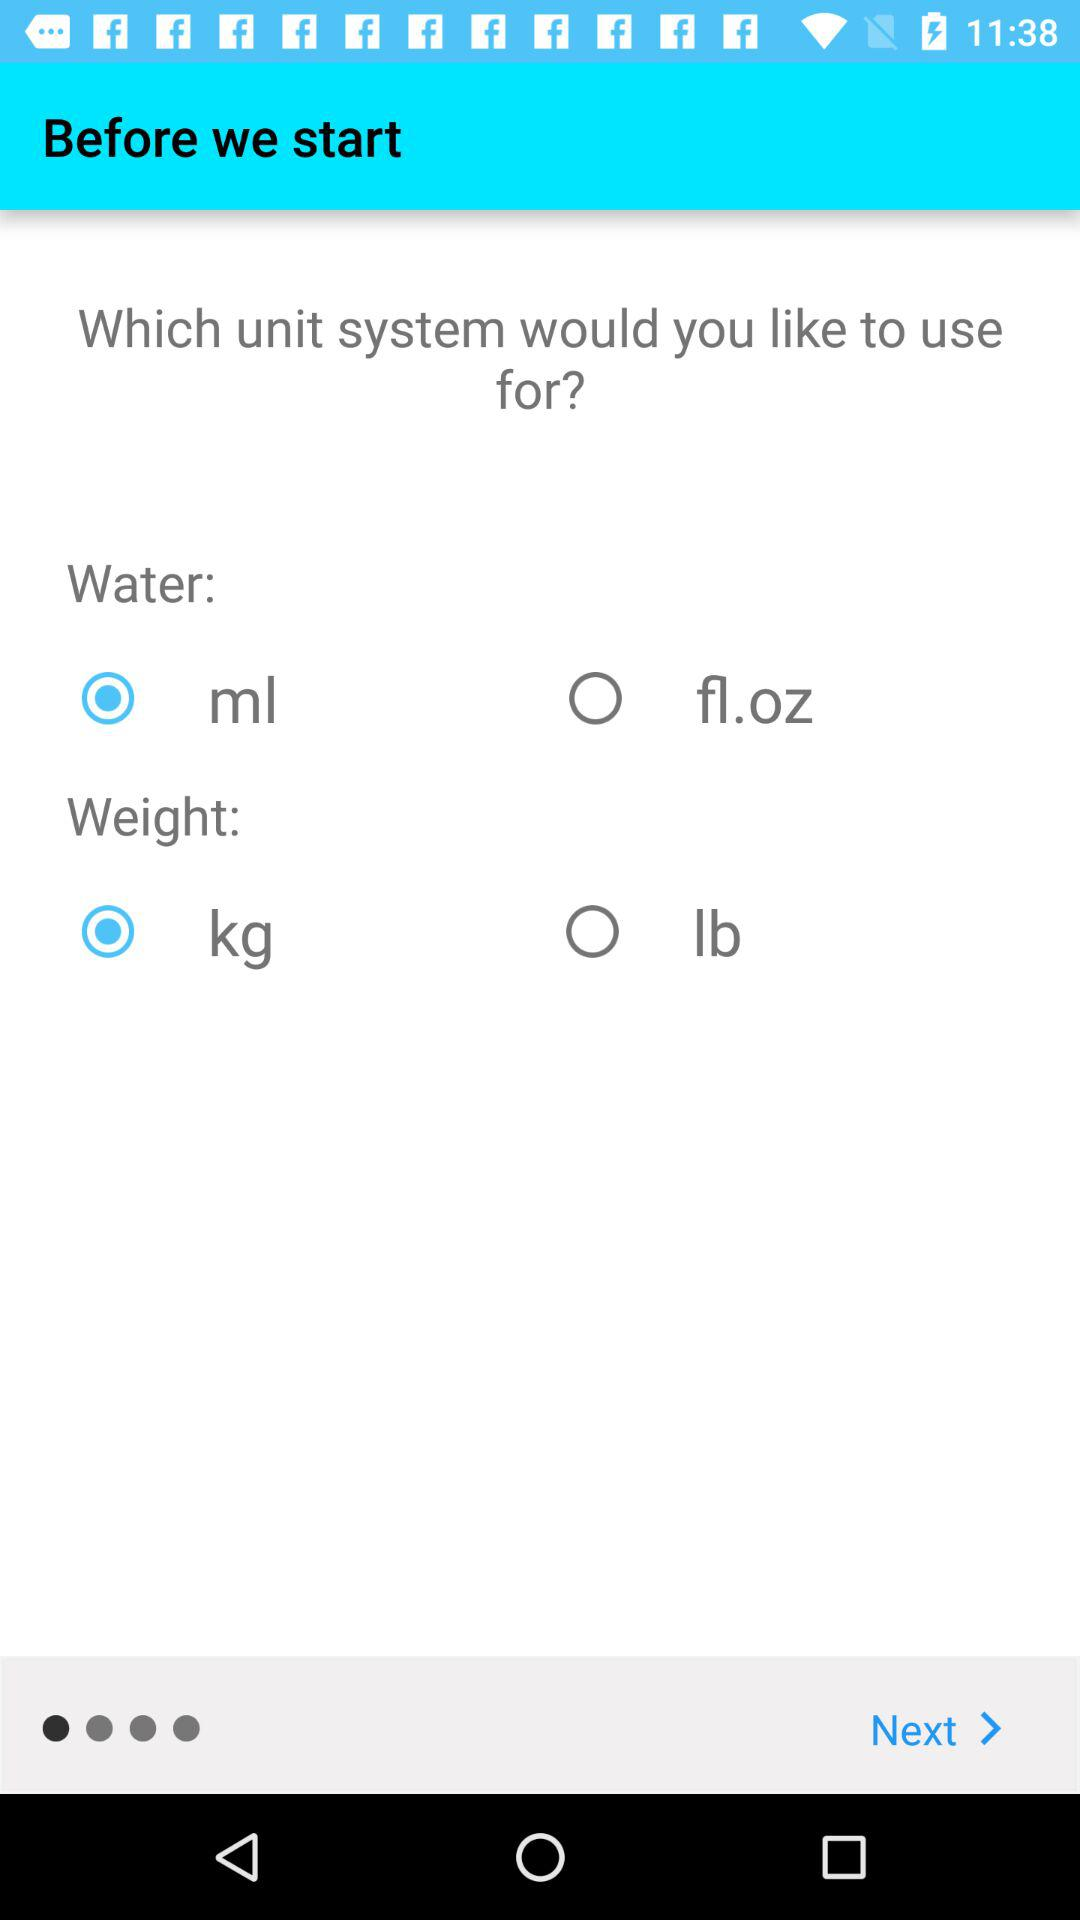Which option has kg as the unit? The option is "Weight". 